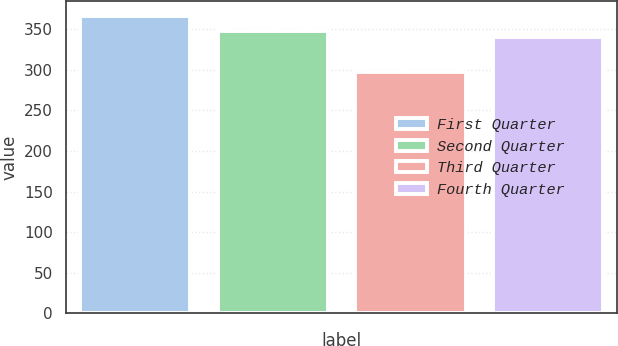Convert chart. <chart><loc_0><loc_0><loc_500><loc_500><bar_chart><fcel>First Quarter<fcel>Second Quarter<fcel>Third Quarter<fcel>Fourth Quarter<nl><fcel>365.84<fcel>347.36<fcel>297.47<fcel>340.52<nl></chart> 